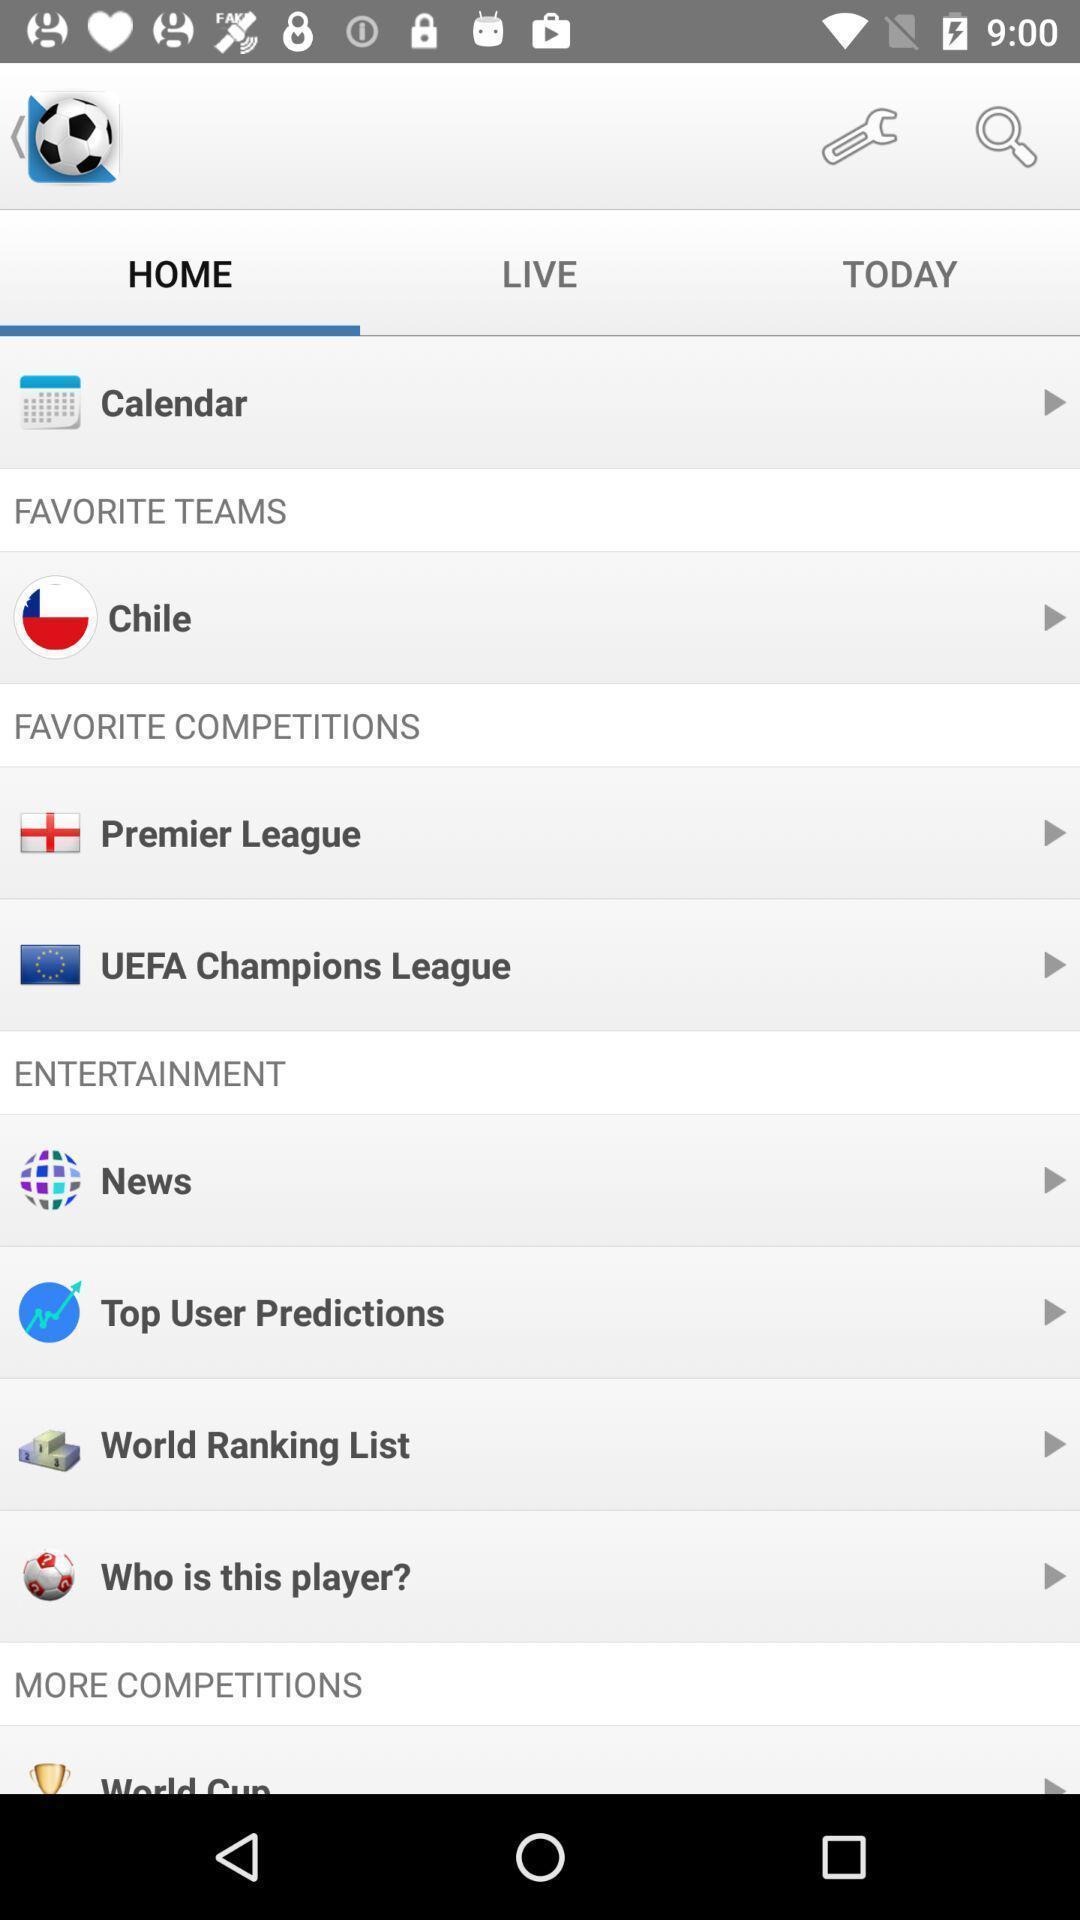Summarize the main components in this picture. Screen shows a home page of favorite teams. 